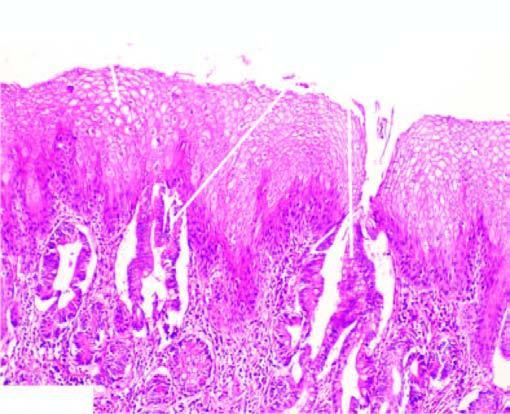does part of the oesophagus which is normally lined by squamous epithelium undergo metaplastic change to columnar epithelium of intestinal type?
Answer the question using a single word or phrase. Yes 